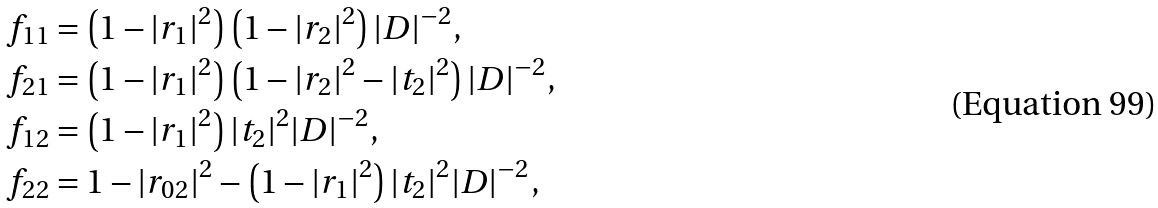Convert formula to latex. <formula><loc_0><loc_0><loc_500><loc_500>f _ { 1 1 } & = \left ( 1 - | r _ { 1 } | ^ { 2 } \right ) \left ( 1 - | r _ { 2 } | ^ { 2 } \right ) | D | ^ { - 2 } , \\ f _ { 2 1 } & = \left ( 1 - | r _ { 1 } | ^ { 2 } \right ) \left ( 1 - | r _ { 2 } | ^ { 2 } - | t _ { 2 } | ^ { 2 } \right ) | D | ^ { - 2 } , \\ f _ { 1 2 } & = \left ( 1 - | r _ { 1 } | ^ { 2 } \right ) | t _ { 2 } | ^ { 2 } | D | ^ { - 2 } , \\ f _ { 2 2 } & = 1 - | r _ { 0 2 } | ^ { 2 } - \left ( 1 - | r _ { 1 } | ^ { 2 } \right ) | t _ { 2 } | ^ { 2 } | D | ^ { - 2 } ,</formula> 